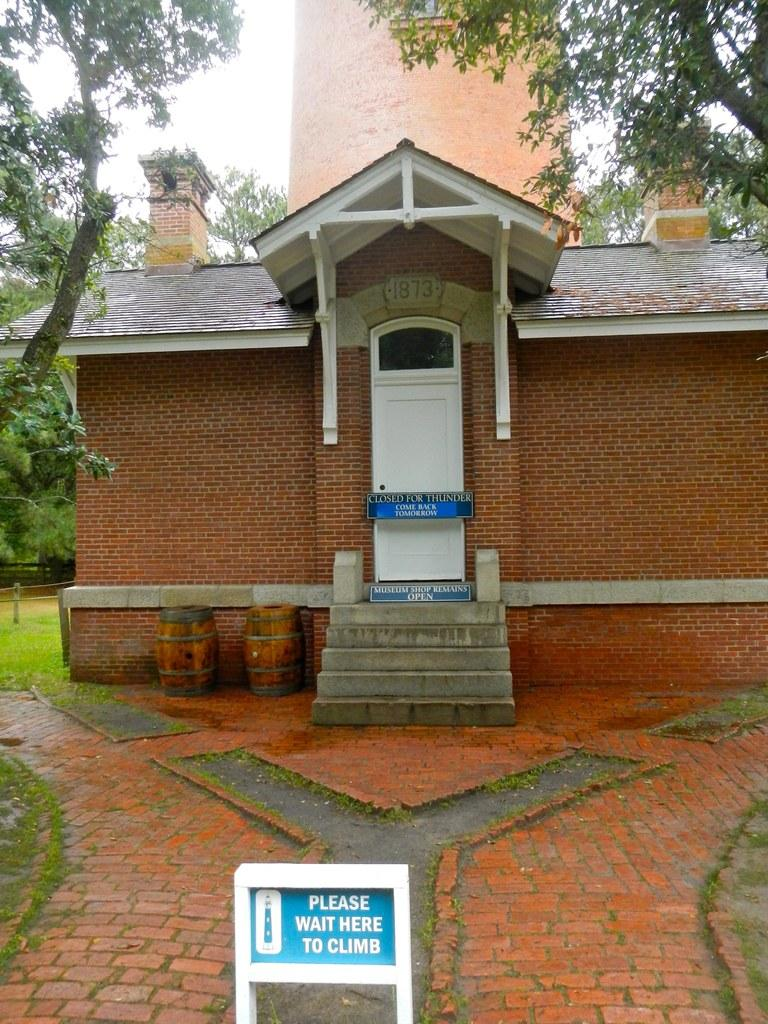What objects are made of wood in the image? There are boards in the image. What type of structure is visible in the image? There is a house and a tower in the image. What are the barrels used for in the image? The purpose of the barrels is not specified in the image. What type of vegetation is present in the image? There is grass and trees in the image. What is visible in the background of the image? The sky is visible in the background of the image. How many dogs are flying through the air in the image? There are no dogs or any indication of flying in the image. What type of blade is being used to cut the grass in the image? There is no blade or grass-cutting activity depicted in the image. 